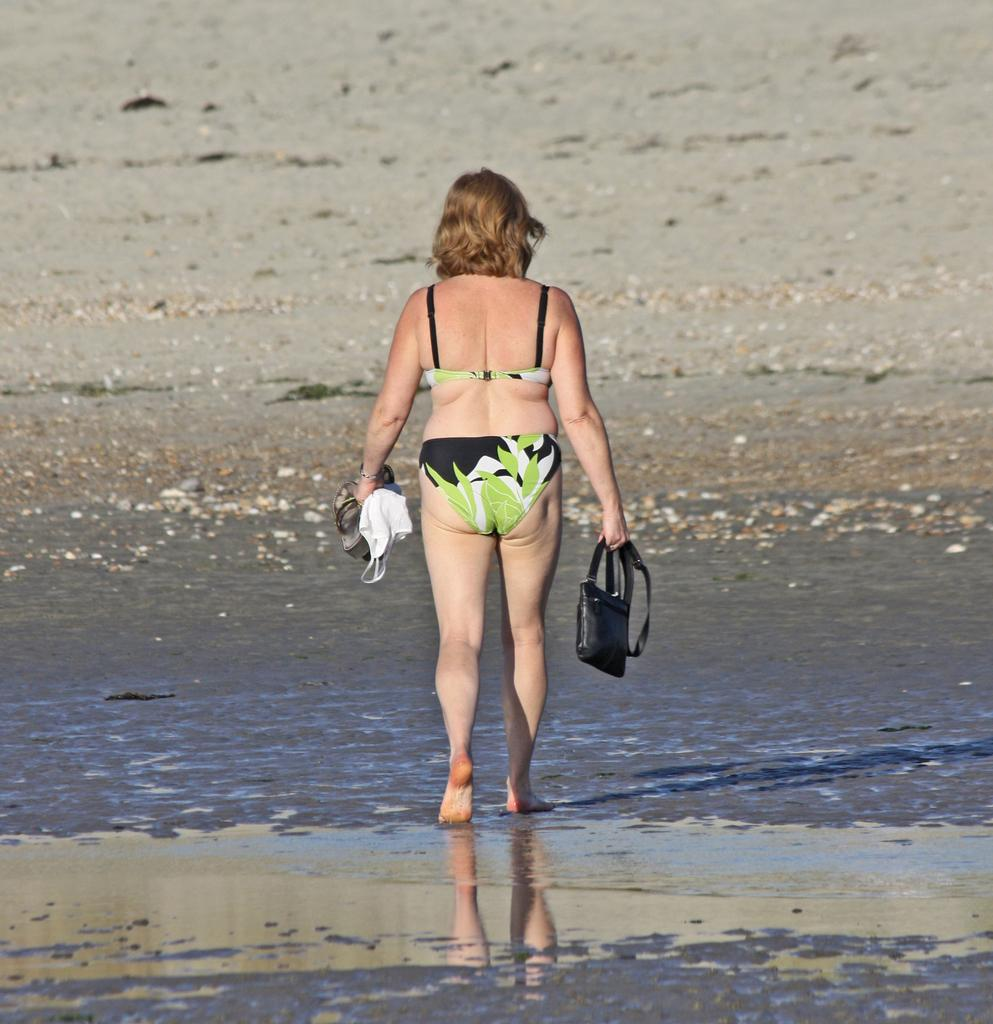What is the main subject of the image? There is a person in the image. What is the person holding in the image? The person is holding a bag and sandals. What type of hole can be seen in the image? There is no hole present in the image. What kind of donkey is visible in the image? There is no donkey present in the image. 